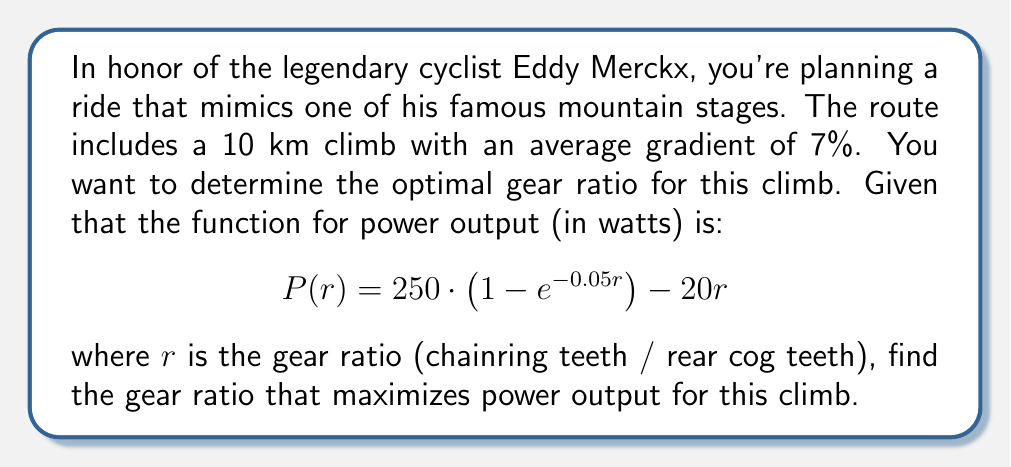Provide a solution to this math problem. To find the optimal gear ratio, we need to maximize the power output function $P(r)$. This can be done by finding the value of $r$ where the derivative of $P(r)$ equals zero.

1) First, let's find the derivative of $P(r)$:
   $$P'(r) = 250 \cdot (0.05e^{-0.05r}) - 20$$

2) Set the derivative equal to zero and solve for $r$:
   $$250 \cdot (0.05e^{-0.05r}) - 20 = 0$$
   $$12.5e^{-0.05r} = 20$$
   $$e^{-0.05r} = 1.6$$

3) Take the natural log of both sides:
   $$-0.05r = \ln(1.6)$$
   $$r = -\frac{\ln(1.6)}{0.05}$$

4) Calculate the value of $r$:
   $$r \approx 9.42$$

5) To confirm this is a maximum, we can check the second derivative:
   $$P''(r) = -12.5e^{-0.05r}$$
   At $r = 9.42$, $P''(r)$ is negative, confirming a maximum.

6) Round to the nearest practical gear ratio:
   $$r \approx 9.4$$

This gear ratio corresponds to a chainring with about 47 teeth and a rear cog with 5 teeth (47/5 ≈ 9.4).
Answer: 9.4 